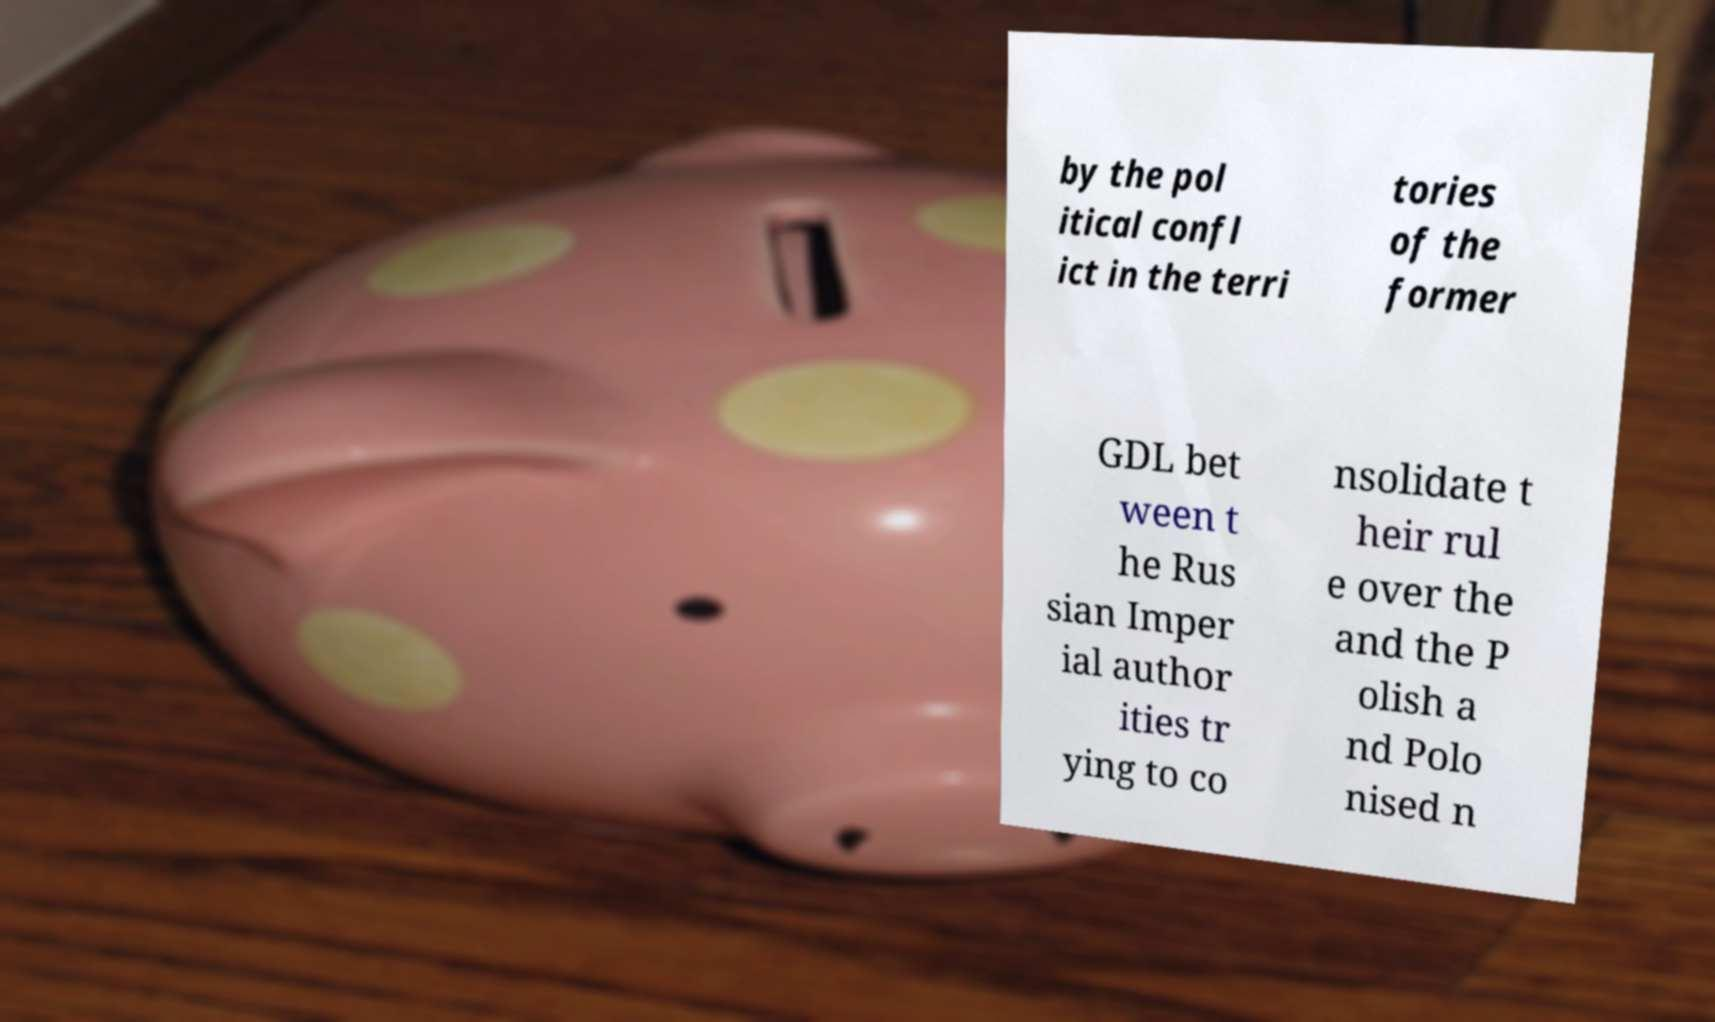Please identify and transcribe the text found in this image. by the pol itical confl ict in the terri tories of the former GDL bet ween t he Rus sian Imper ial author ities tr ying to co nsolidate t heir rul e over the and the P olish a nd Polo nised n 